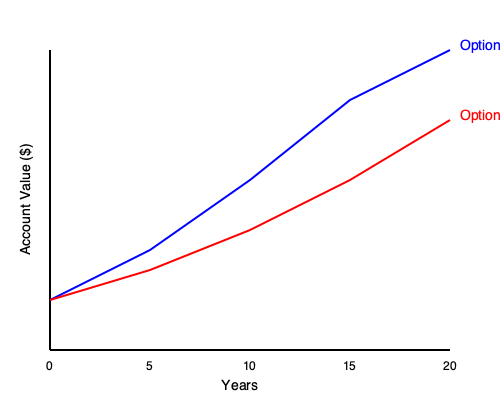Looking at the graph showing two 529 plan investment options over 20 years, which option appears to grow faster and potentially provide more money for college expenses? To determine which option grows faster and potentially provides more money for college expenses, we need to compare the two lines on the graph:

1. The blue line represents Option A, and the red line represents Option B.

2. Both options start at the same point at year 0.

3. As we move from left to right (representing time passing):
   - The blue line (Option A) rises more steeply than the red line (Option B).
   - This means Option A is growing at a faster rate.

4. By the end of the 20-year period:
   - The blue line (Option A) reaches a higher point on the vertical axis.
   - This indicates that Option A has accumulated more money over time.

5. The vertical axis represents the account value in dollars. Option A ends up higher on this axis, meaning it has a larger final account balance.

6. A larger account balance at the end of the investment period means more money available for college expenses.

Therefore, based on the graph, Option A appears to grow faster and would likely provide more money for college expenses after 20 years.
Answer: Option A 